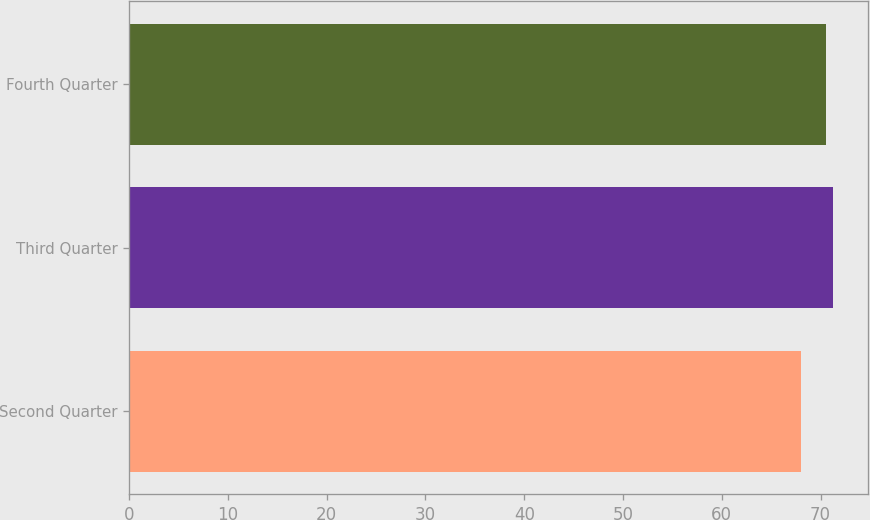Convert chart. <chart><loc_0><loc_0><loc_500><loc_500><bar_chart><fcel>Second Quarter<fcel>Third Quarter<fcel>Fourth Quarter<nl><fcel>67.97<fcel>71.26<fcel>70.6<nl></chart> 